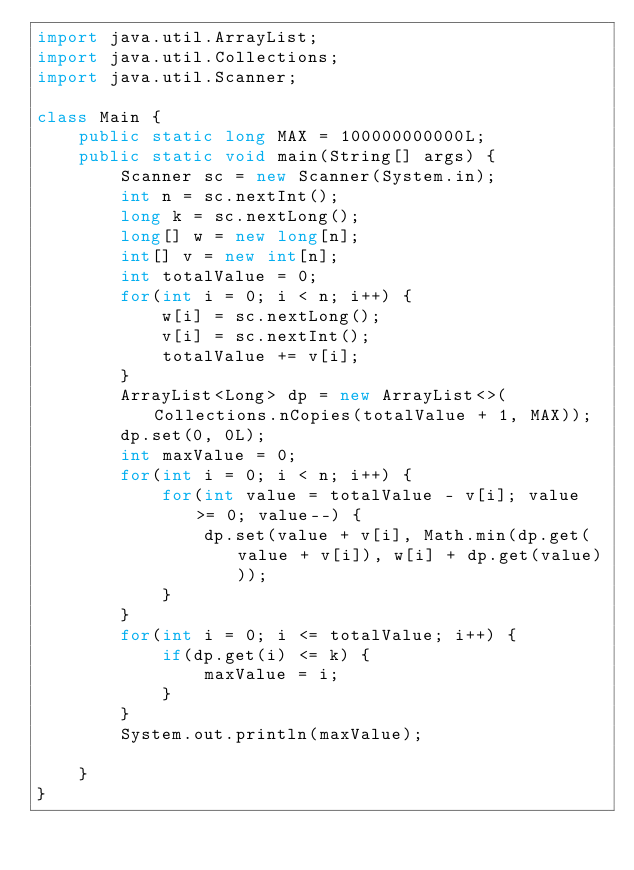<code> <loc_0><loc_0><loc_500><loc_500><_Java_>import java.util.ArrayList;
import java.util.Collections;
import java.util.Scanner;

class Main {
    public static long MAX = 100000000000L;
    public static void main(String[] args) {
        Scanner sc = new Scanner(System.in);
        int n = sc.nextInt();
        long k = sc.nextLong();
        long[] w = new long[n];
        int[] v = new int[n];
        int totalValue = 0;
        for(int i = 0; i < n; i++) {
            w[i] = sc.nextLong();
            v[i] = sc.nextInt();
            totalValue += v[i];
        }
        ArrayList<Long> dp = new ArrayList<>(Collections.nCopies(totalValue + 1, MAX));
        dp.set(0, 0L);
        int maxValue = 0;
        for(int i = 0; i < n; i++) {
            for(int value = totalValue - v[i]; value >= 0; value--) {
                dp.set(value + v[i], Math.min(dp.get(value + v[i]), w[i] + dp.get(value)));
            }
        }
        for(int i = 0; i <= totalValue; i++) {
            if(dp.get(i) <= k) {
                maxValue = i;
            }
        }
        System.out.println(maxValue);

    }
}
</code> 